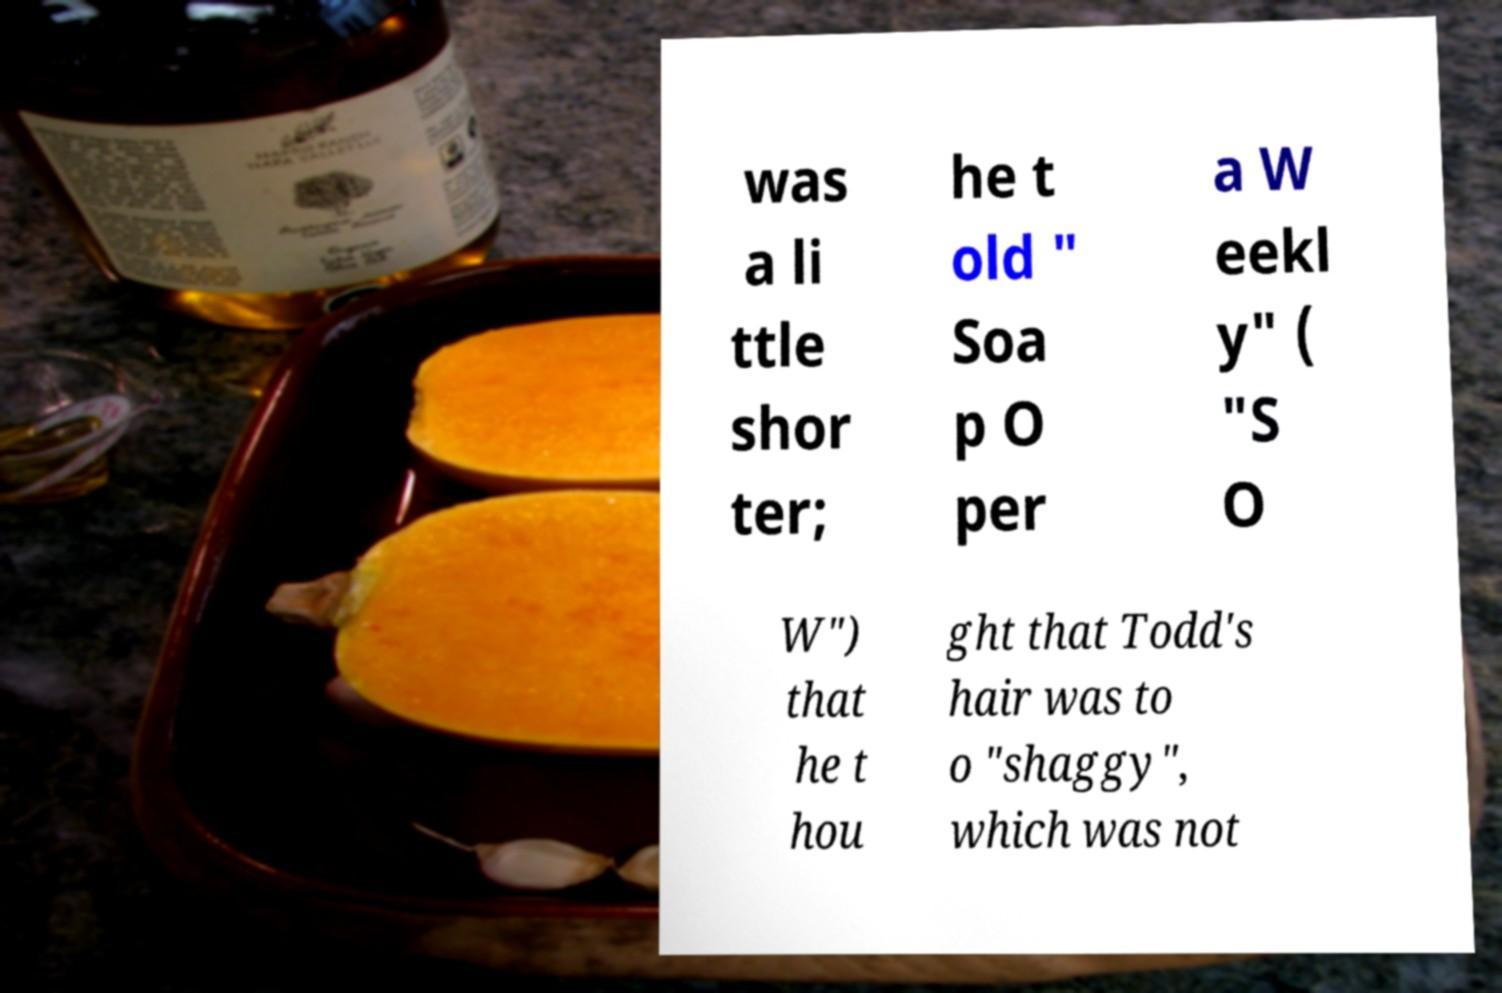Could you assist in decoding the text presented in this image and type it out clearly? was a li ttle shor ter; he t old " Soa p O per a W eekl y" ( "S O W") that he t hou ght that Todd's hair was to o "shaggy", which was not 